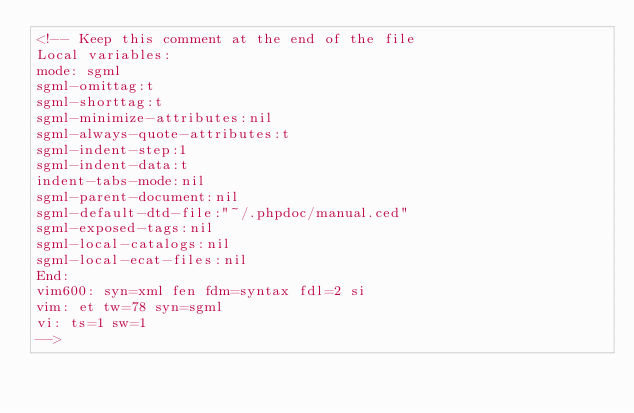<code> <loc_0><loc_0><loc_500><loc_500><_XML_><!-- Keep this comment at the end of the file
Local variables:
mode: sgml
sgml-omittag:t
sgml-shorttag:t
sgml-minimize-attributes:nil
sgml-always-quote-attributes:t
sgml-indent-step:1
sgml-indent-data:t
indent-tabs-mode:nil
sgml-parent-document:nil
sgml-default-dtd-file:"~/.phpdoc/manual.ced"
sgml-exposed-tags:nil
sgml-local-catalogs:nil
sgml-local-ecat-files:nil
End:
vim600: syn=xml fen fdm=syntax fdl=2 si
vim: et tw=78 syn=sgml
vi: ts=1 sw=1
-->
</code> 